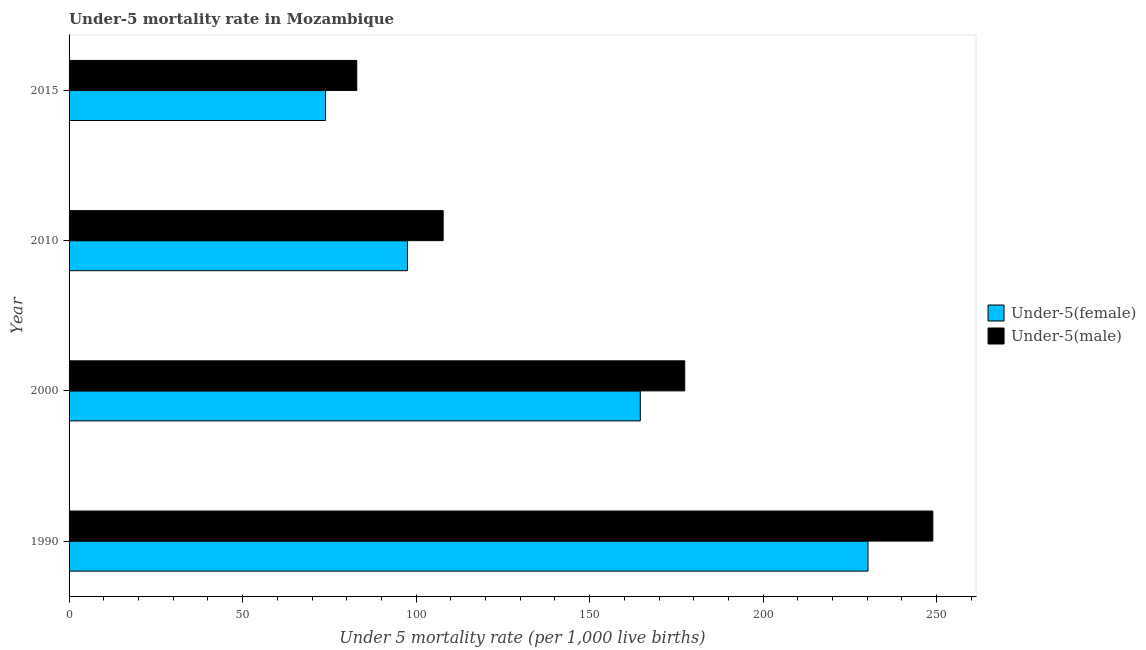How many different coloured bars are there?
Your response must be concise. 2. How many groups of bars are there?
Provide a short and direct response. 4. Are the number of bars per tick equal to the number of legend labels?
Offer a terse response. Yes. Are the number of bars on each tick of the Y-axis equal?
Provide a short and direct response. Yes. How many bars are there on the 3rd tick from the top?
Ensure brevity in your answer.  2. What is the under-5 male mortality rate in 2000?
Give a very brief answer. 177.4. Across all years, what is the maximum under-5 female mortality rate?
Offer a terse response. 230.2. Across all years, what is the minimum under-5 female mortality rate?
Offer a very short reply. 73.9. In which year was the under-5 male mortality rate maximum?
Provide a succinct answer. 1990. In which year was the under-5 male mortality rate minimum?
Offer a terse response. 2015. What is the total under-5 female mortality rate in the graph?
Make the answer very short. 566.2. What is the difference between the under-5 female mortality rate in 1990 and that in 2000?
Your response must be concise. 65.6. What is the difference between the under-5 male mortality rate in 2015 and the under-5 female mortality rate in 2000?
Your answer should be compact. -81.7. What is the average under-5 male mortality rate per year?
Give a very brief answer. 154.25. In the year 2000, what is the difference between the under-5 female mortality rate and under-5 male mortality rate?
Provide a short and direct response. -12.8. In how many years, is the under-5 female mortality rate greater than 140 ?
Your response must be concise. 2. What is the ratio of the under-5 female mortality rate in 1990 to that in 2000?
Your answer should be very brief. 1.4. Is the under-5 male mortality rate in 2000 less than that in 2010?
Make the answer very short. No. What is the difference between the highest and the second highest under-5 female mortality rate?
Provide a succinct answer. 65.6. What is the difference between the highest and the lowest under-5 male mortality rate?
Offer a very short reply. 166. In how many years, is the under-5 female mortality rate greater than the average under-5 female mortality rate taken over all years?
Your response must be concise. 2. Is the sum of the under-5 female mortality rate in 1990 and 2010 greater than the maximum under-5 male mortality rate across all years?
Give a very brief answer. Yes. What does the 1st bar from the top in 2015 represents?
Keep it short and to the point. Under-5(male). What does the 2nd bar from the bottom in 2015 represents?
Your answer should be compact. Under-5(male). Are all the bars in the graph horizontal?
Offer a very short reply. Yes. What is the difference between two consecutive major ticks on the X-axis?
Ensure brevity in your answer.  50. Does the graph contain any zero values?
Provide a short and direct response. No. Does the graph contain grids?
Provide a succinct answer. No. Where does the legend appear in the graph?
Keep it short and to the point. Center right. How are the legend labels stacked?
Make the answer very short. Vertical. What is the title of the graph?
Offer a very short reply. Under-5 mortality rate in Mozambique. Does "International Tourists" appear as one of the legend labels in the graph?
Your answer should be compact. No. What is the label or title of the X-axis?
Offer a terse response. Under 5 mortality rate (per 1,0 live births). What is the Under 5 mortality rate (per 1,000 live births) of Under-5(female) in 1990?
Your response must be concise. 230.2. What is the Under 5 mortality rate (per 1,000 live births) of Under-5(male) in 1990?
Offer a terse response. 248.9. What is the Under 5 mortality rate (per 1,000 live births) of Under-5(female) in 2000?
Your answer should be very brief. 164.6. What is the Under 5 mortality rate (per 1,000 live births) in Under-5(male) in 2000?
Provide a short and direct response. 177.4. What is the Under 5 mortality rate (per 1,000 live births) in Under-5(female) in 2010?
Your answer should be compact. 97.5. What is the Under 5 mortality rate (per 1,000 live births) of Under-5(male) in 2010?
Your response must be concise. 107.8. What is the Under 5 mortality rate (per 1,000 live births) of Under-5(female) in 2015?
Give a very brief answer. 73.9. What is the Under 5 mortality rate (per 1,000 live births) in Under-5(male) in 2015?
Your answer should be very brief. 82.9. Across all years, what is the maximum Under 5 mortality rate (per 1,000 live births) of Under-5(female)?
Provide a succinct answer. 230.2. Across all years, what is the maximum Under 5 mortality rate (per 1,000 live births) in Under-5(male)?
Keep it short and to the point. 248.9. Across all years, what is the minimum Under 5 mortality rate (per 1,000 live births) in Under-5(female)?
Offer a very short reply. 73.9. Across all years, what is the minimum Under 5 mortality rate (per 1,000 live births) of Under-5(male)?
Keep it short and to the point. 82.9. What is the total Under 5 mortality rate (per 1,000 live births) in Under-5(female) in the graph?
Provide a short and direct response. 566.2. What is the total Under 5 mortality rate (per 1,000 live births) of Under-5(male) in the graph?
Offer a terse response. 617. What is the difference between the Under 5 mortality rate (per 1,000 live births) of Under-5(female) in 1990 and that in 2000?
Your response must be concise. 65.6. What is the difference between the Under 5 mortality rate (per 1,000 live births) of Under-5(male) in 1990 and that in 2000?
Your answer should be very brief. 71.5. What is the difference between the Under 5 mortality rate (per 1,000 live births) of Under-5(female) in 1990 and that in 2010?
Offer a terse response. 132.7. What is the difference between the Under 5 mortality rate (per 1,000 live births) of Under-5(male) in 1990 and that in 2010?
Offer a very short reply. 141.1. What is the difference between the Under 5 mortality rate (per 1,000 live births) in Under-5(female) in 1990 and that in 2015?
Give a very brief answer. 156.3. What is the difference between the Under 5 mortality rate (per 1,000 live births) in Under-5(male) in 1990 and that in 2015?
Offer a terse response. 166. What is the difference between the Under 5 mortality rate (per 1,000 live births) in Under-5(female) in 2000 and that in 2010?
Give a very brief answer. 67.1. What is the difference between the Under 5 mortality rate (per 1,000 live births) of Under-5(male) in 2000 and that in 2010?
Offer a terse response. 69.6. What is the difference between the Under 5 mortality rate (per 1,000 live births) in Under-5(female) in 2000 and that in 2015?
Your answer should be very brief. 90.7. What is the difference between the Under 5 mortality rate (per 1,000 live births) of Under-5(male) in 2000 and that in 2015?
Your response must be concise. 94.5. What is the difference between the Under 5 mortality rate (per 1,000 live births) of Under-5(female) in 2010 and that in 2015?
Make the answer very short. 23.6. What is the difference between the Under 5 mortality rate (per 1,000 live births) in Under-5(male) in 2010 and that in 2015?
Offer a terse response. 24.9. What is the difference between the Under 5 mortality rate (per 1,000 live births) of Under-5(female) in 1990 and the Under 5 mortality rate (per 1,000 live births) of Under-5(male) in 2000?
Offer a very short reply. 52.8. What is the difference between the Under 5 mortality rate (per 1,000 live births) of Under-5(female) in 1990 and the Under 5 mortality rate (per 1,000 live births) of Under-5(male) in 2010?
Keep it short and to the point. 122.4. What is the difference between the Under 5 mortality rate (per 1,000 live births) of Under-5(female) in 1990 and the Under 5 mortality rate (per 1,000 live births) of Under-5(male) in 2015?
Provide a short and direct response. 147.3. What is the difference between the Under 5 mortality rate (per 1,000 live births) in Under-5(female) in 2000 and the Under 5 mortality rate (per 1,000 live births) in Under-5(male) in 2010?
Make the answer very short. 56.8. What is the difference between the Under 5 mortality rate (per 1,000 live births) in Under-5(female) in 2000 and the Under 5 mortality rate (per 1,000 live births) in Under-5(male) in 2015?
Ensure brevity in your answer.  81.7. What is the average Under 5 mortality rate (per 1,000 live births) in Under-5(female) per year?
Offer a terse response. 141.55. What is the average Under 5 mortality rate (per 1,000 live births) in Under-5(male) per year?
Offer a very short reply. 154.25. In the year 1990, what is the difference between the Under 5 mortality rate (per 1,000 live births) in Under-5(female) and Under 5 mortality rate (per 1,000 live births) in Under-5(male)?
Your answer should be very brief. -18.7. In the year 2015, what is the difference between the Under 5 mortality rate (per 1,000 live births) of Under-5(female) and Under 5 mortality rate (per 1,000 live births) of Under-5(male)?
Your response must be concise. -9. What is the ratio of the Under 5 mortality rate (per 1,000 live births) of Under-5(female) in 1990 to that in 2000?
Provide a short and direct response. 1.4. What is the ratio of the Under 5 mortality rate (per 1,000 live births) in Under-5(male) in 1990 to that in 2000?
Provide a short and direct response. 1.4. What is the ratio of the Under 5 mortality rate (per 1,000 live births) of Under-5(female) in 1990 to that in 2010?
Ensure brevity in your answer.  2.36. What is the ratio of the Under 5 mortality rate (per 1,000 live births) in Under-5(male) in 1990 to that in 2010?
Offer a terse response. 2.31. What is the ratio of the Under 5 mortality rate (per 1,000 live births) in Under-5(female) in 1990 to that in 2015?
Offer a very short reply. 3.12. What is the ratio of the Under 5 mortality rate (per 1,000 live births) in Under-5(male) in 1990 to that in 2015?
Give a very brief answer. 3. What is the ratio of the Under 5 mortality rate (per 1,000 live births) in Under-5(female) in 2000 to that in 2010?
Your answer should be very brief. 1.69. What is the ratio of the Under 5 mortality rate (per 1,000 live births) in Under-5(male) in 2000 to that in 2010?
Keep it short and to the point. 1.65. What is the ratio of the Under 5 mortality rate (per 1,000 live births) in Under-5(female) in 2000 to that in 2015?
Offer a terse response. 2.23. What is the ratio of the Under 5 mortality rate (per 1,000 live births) in Under-5(male) in 2000 to that in 2015?
Offer a terse response. 2.14. What is the ratio of the Under 5 mortality rate (per 1,000 live births) of Under-5(female) in 2010 to that in 2015?
Ensure brevity in your answer.  1.32. What is the ratio of the Under 5 mortality rate (per 1,000 live births) in Under-5(male) in 2010 to that in 2015?
Keep it short and to the point. 1.3. What is the difference between the highest and the second highest Under 5 mortality rate (per 1,000 live births) in Under-5(female)?
Your response must be concise. 65.6. What is the difference between the highest and the second highest Under 5 mortality rate (per 1,000 live births) in Under-5(male)?
Keep it short and to the point. 71.5. What is the difference between the highest and the lowest Under 5 mortality rate (per 1,000 live births) of Under-5(female)?
Provide a short and direct response. 156.3. What is the difference between the highest and the lowest Under 5 mortality rate (per 1,000 live births) in Under-5(male)?
Offer a terse response. 166. 